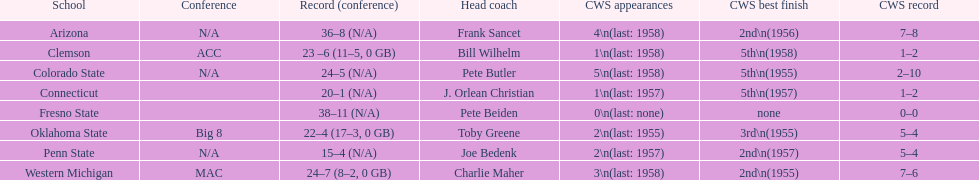Which school has zero college world series appearances? Fresno State. 